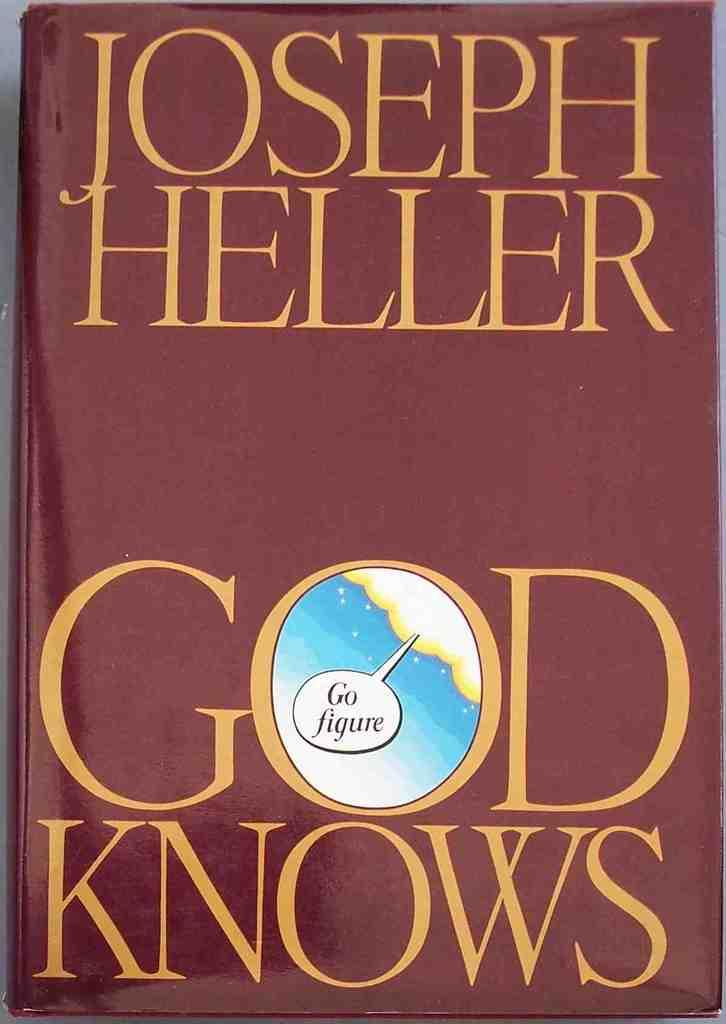<image>
Create a compact narrative representing the image presented. A hardcover copy of God Knows features a little cloud in the center of the letter O. 